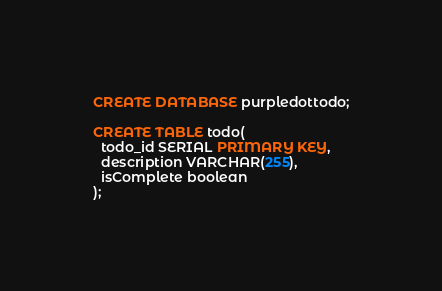<code> <loc_0><loc_0><loc_500><loc_500><_SQL_>CREATE DATABASE purpledottodo;

CREATE TABLE todo(
  todo_id SERIAL PRIMARY KEY,
  description VARCHAR(255),
  isComplete boolean
);</code> 